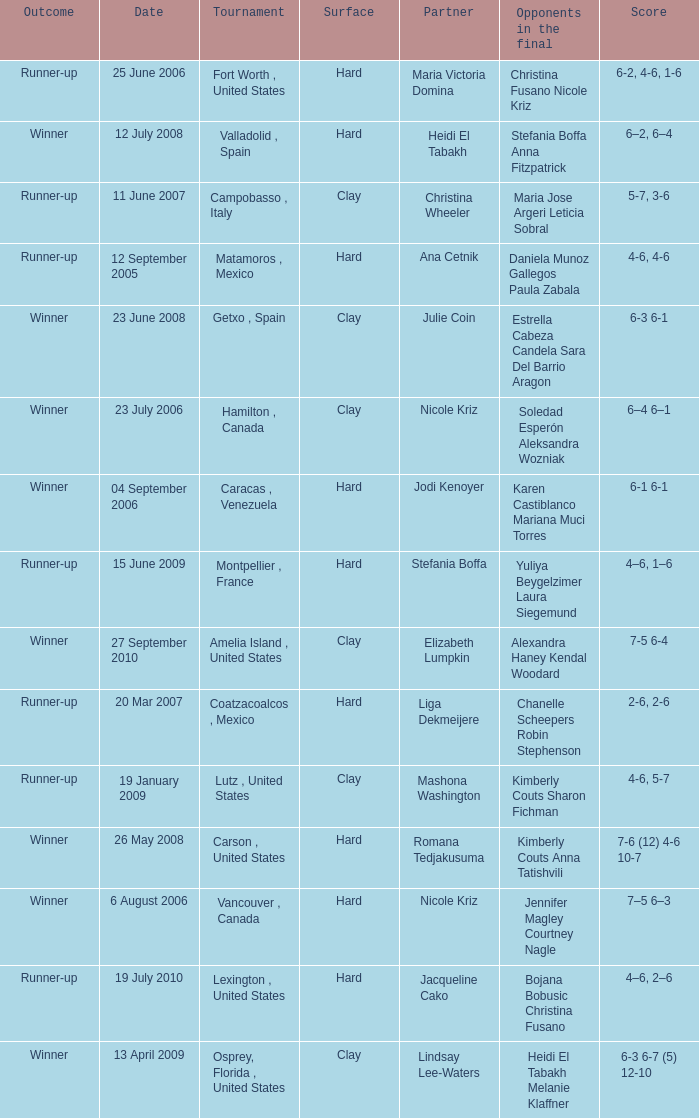Who were the opponents during the final when christina wheeler was partner? Maria Jose Argeri Leticia Sobral. 